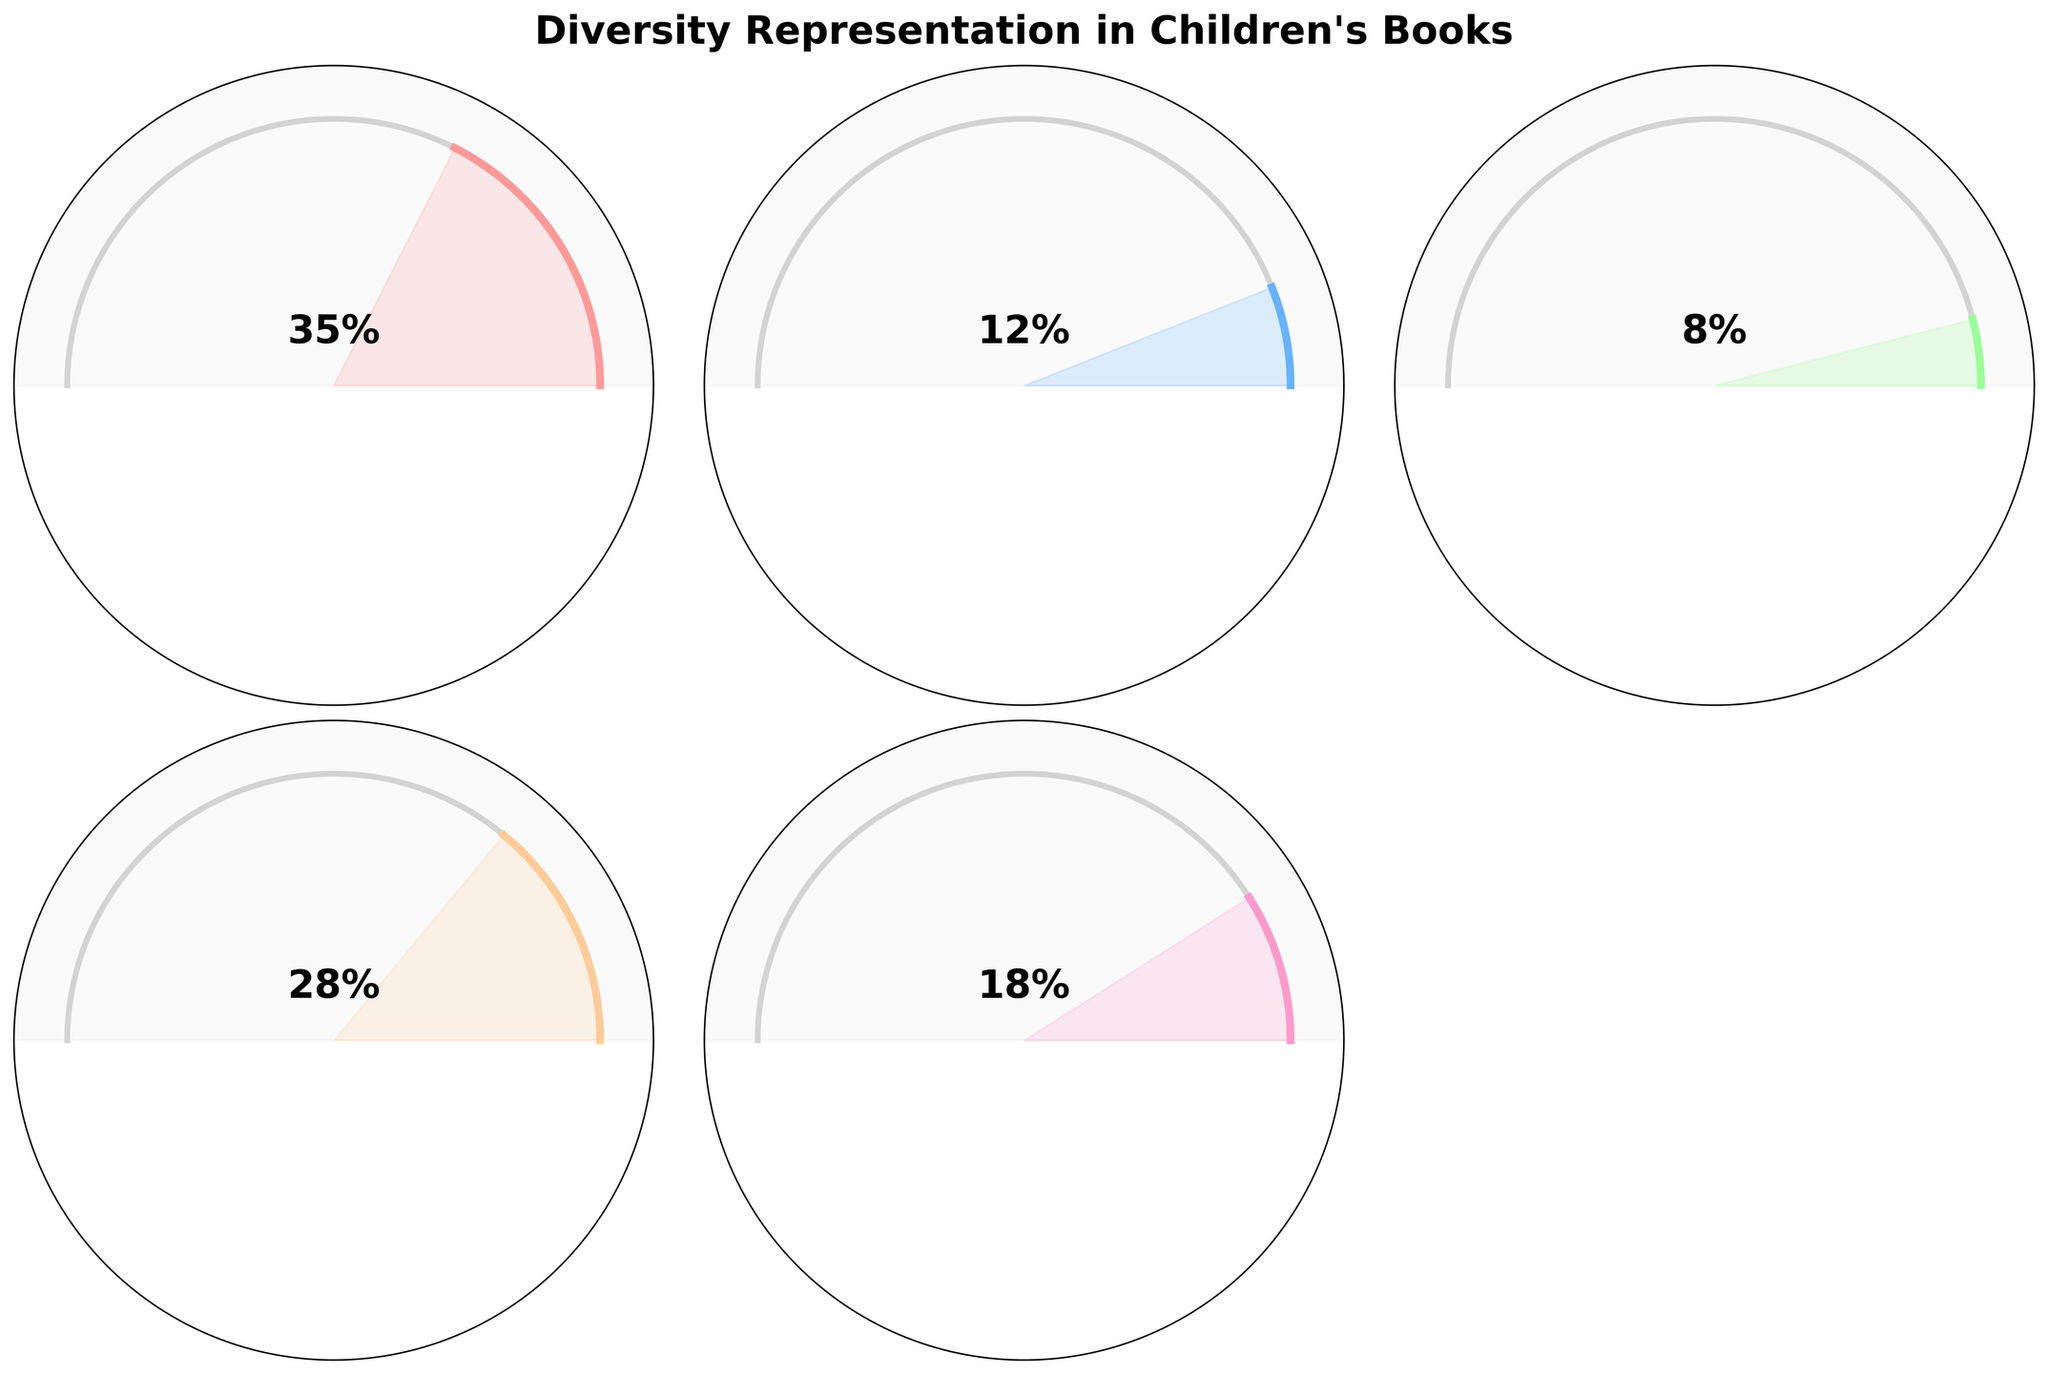What percentage of books have Multicultural Themes? Look at the gauge chart titled "Books with Multicultural Themes" and check the percentage indicated in the center.
Answer: 28% What is the highest percentage representation, and which category does it belong to? Compare all gauge charts and note the percentages. The highest percentage is 35% which belongs to "Books with BIPOC Characters".
Answer: 35%, Books with BIPOC Characters How much more percentage representation do Books with BIPOC Characters have compared to Books with Disability Representation? Subtract the percentage of Books with Disability Representation (8%) from Books with BIPOC Characters (35%). 35 - 8 = 27.
Answer: 27% Which category has the least percentage representation? Look at all the gauge charts and compare the percentages to see which one is the smallest. The smallest percentage is 8%, which belongs to "Books with Disability Representation".
Answer: Books with Disability Representation What is the combined percentage representation of Books with Gender Diversity and LGBTQ+ Characters? Add the percentages of Books with Gender Diversity (18%) and LGBTQ+ Characters (12%). 18 + 12 = 30.
Answer: 30% Compare the percentage representation of Books with Multicultural Themes and Gender Diversity. Which one is higher and by how much? Subtract the percentage of Books with Gender Diversity (18%) from Books with Multicultural Themes (28%). The difference is 28 - 18 = 10, and Books with Multicultural Themes is higher.
Answer: Multicultural Themes, 10 What is the average percentage representation of all the categories? Add all the percentages (35 + 12 + 8 + 28 + 18 = 101) and divide by the number of categories (5). So, the average is 101 / 5 = 20.2.
Answer: 20.2% Are there more books with BIPOC Characters or books with Multicultural Themes? Compare the percentages of Books with BIPOC Characters (35%) and Books with Multicultural Themes (28%). Books with BIPOC Characters have a higher percentage.
Answer: BIPOC Characters How does the representation of Books with Disability compare to Books with LGBTQ+ Characters? Which one is smaller and by how much? Subtract the percentage of Books with Disability Representation (8%) from Books with LGBTQ+ Characters (12%). The difference is 12 - 8 = 4, and Books with Disability Representation is smaller.
Answer: Disability Representation, 4 Is the percentage of Books with Multicultural Themes nearly equal to Books with BIPOC Characters? Compare the percentages of Books with Multicultural Themes (28%) and Books with BIPOC Characters (35%). They are not equal, with a difference of 35 - 28 = 7.
Answer: No, 7 